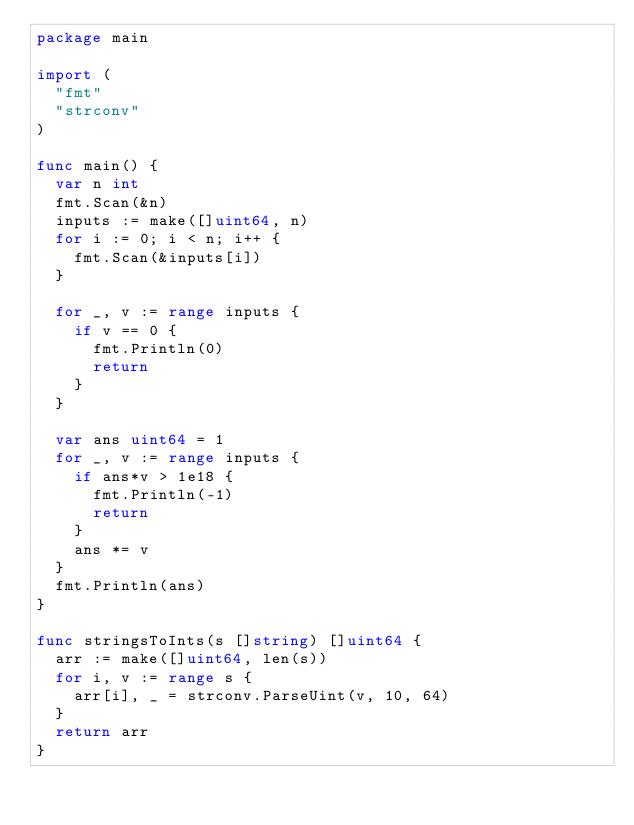<code> <loc_0><loc_0><loc_500><loc_500><_Go_>package main

import (
	"fmt"
	"strconv"
)

func main() {
	var n int
	fmt.Scan(&n)
	inputs := make([]uint64, n)
	for i := 0; i < n; i++ {
		fmt.Scan(&inputs[i])
	}

	for _, v := range inputs {
		if v == 0 {
			fmt.Println(0)
			return
		}
	}

	var ans uint64 = 1
	for _, v := range inputs {
		if ans*v > 1e18 {
			fmt.Println(-1)
			return
		}
		ans *= v
	}
	fmt.Println(ans)
}

func stringsToInts(s []string) []uint64 {
	arr := make([]uint64, len(s))
	for i, v := range s {
		arr[i], _ = strconv.ParseUint(v, 10, 64)
	}
	return arr
}
</code> 